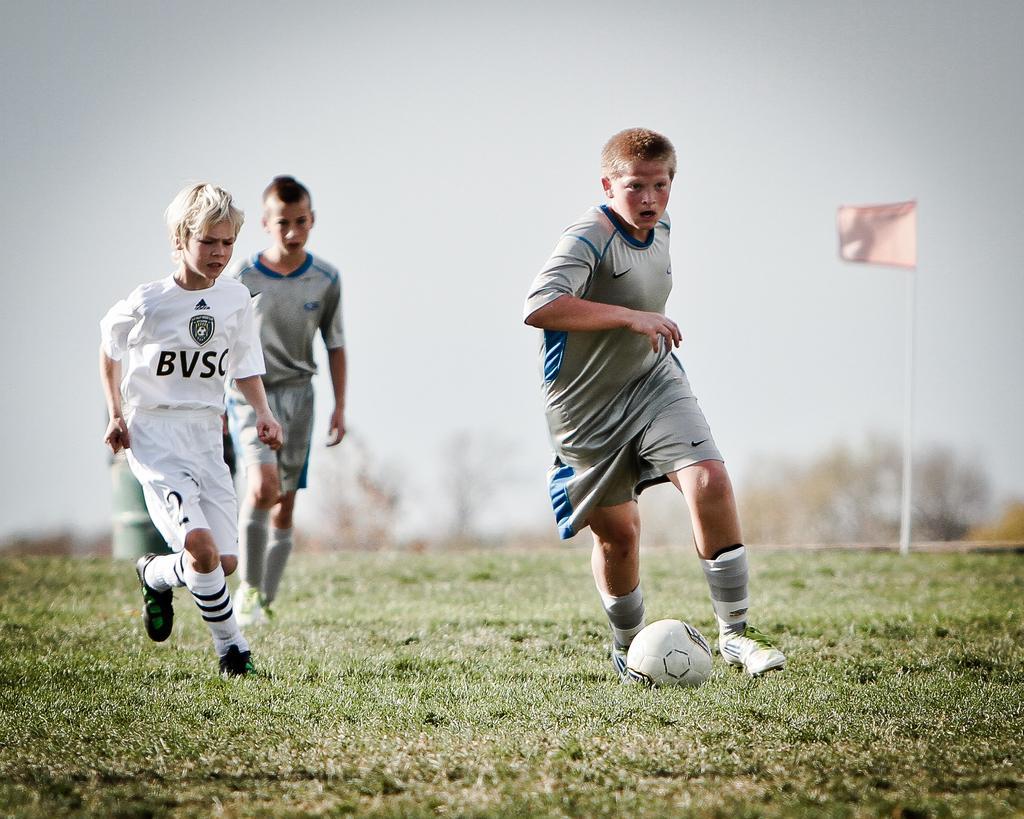Please provide a concise description of this image. This is a picture of three sports person who are on the field wearing their jerseys and shoe. 